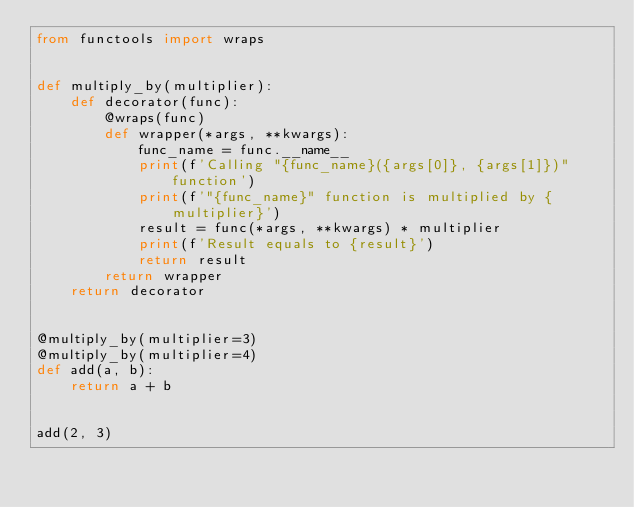Convert code to text. <code><loc_0><loc_0><loc_500><loc_500><_Python_>from functools import wraps


def multiply_by(multiplier):
    def decorator(func):
        @wraps(func)
        def wrapper(*args, **kwargs):
            func_name = func.__name__
            print(f'Calling "{func_name}({args[0]}, {args[1]})" function')
            print(f'"{func_name}" function is multiplied by {multiplier}')
            result = func(*args, **kwargs) * multiplier
            print(f'Result equals to {result}')
            return result
        return wrapper
    return decorator


@multiply_by(multiplier=3)
@multiply_by(multiplier=4)
def add(a, b):
    return a + b


add(2, 3)
</code> 